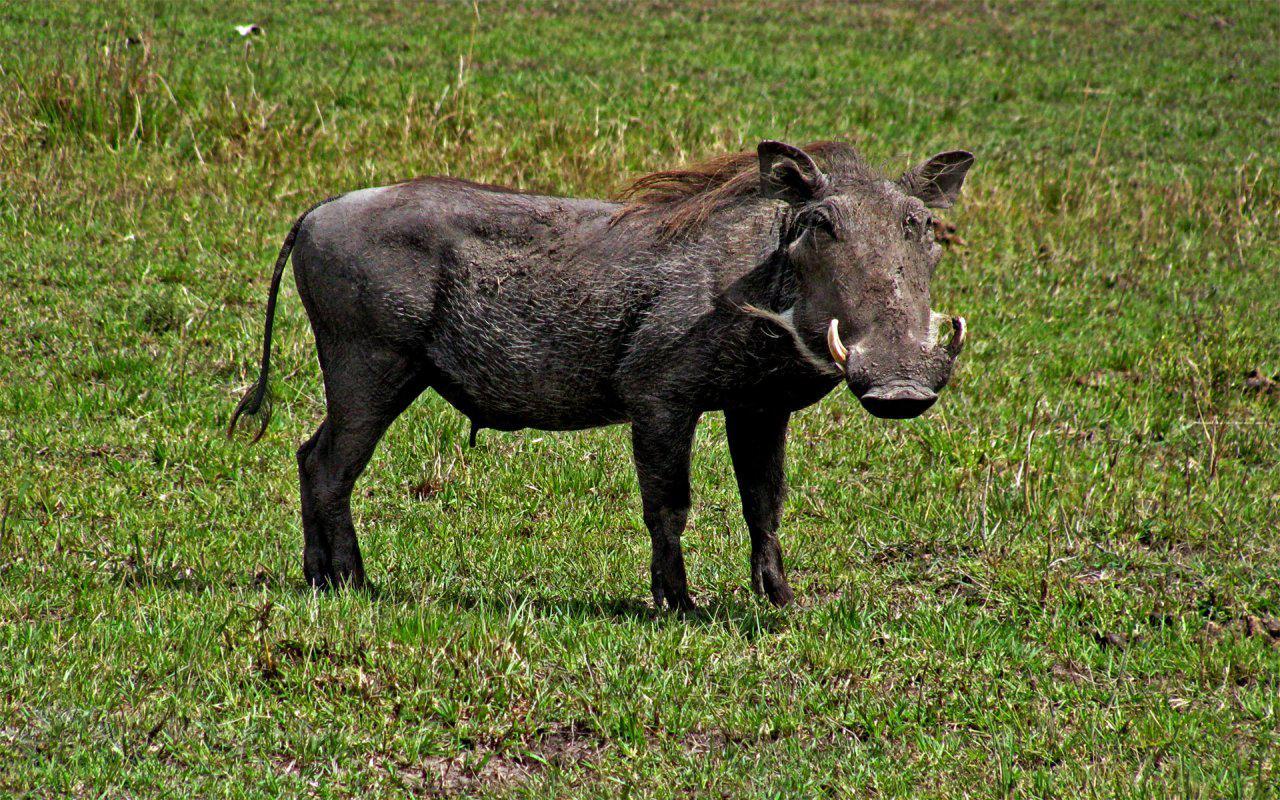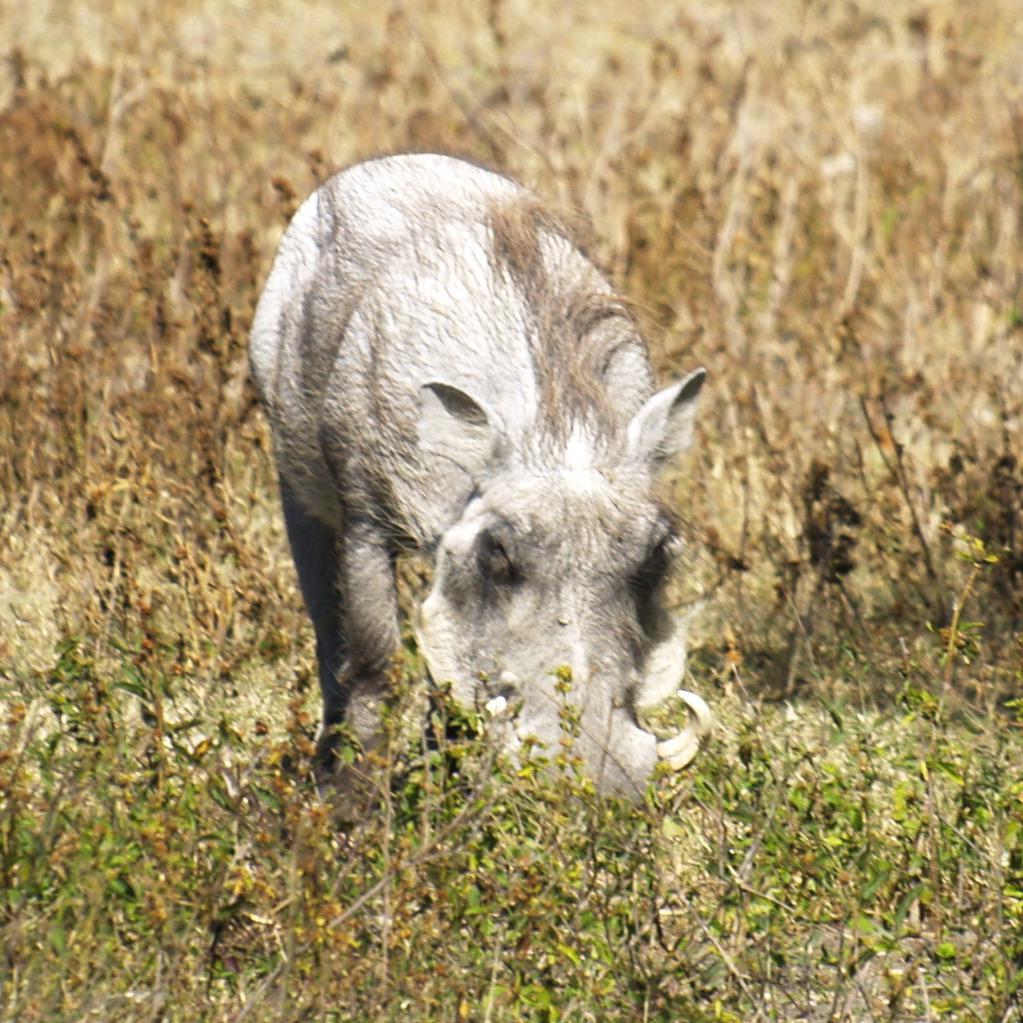The first image is the image on the left, the second image is the image on the right. Examine the images to the left and right. Is the description "The hog on the right has it's mouth on the ground." accurate? Answer yes or no. Yes. 